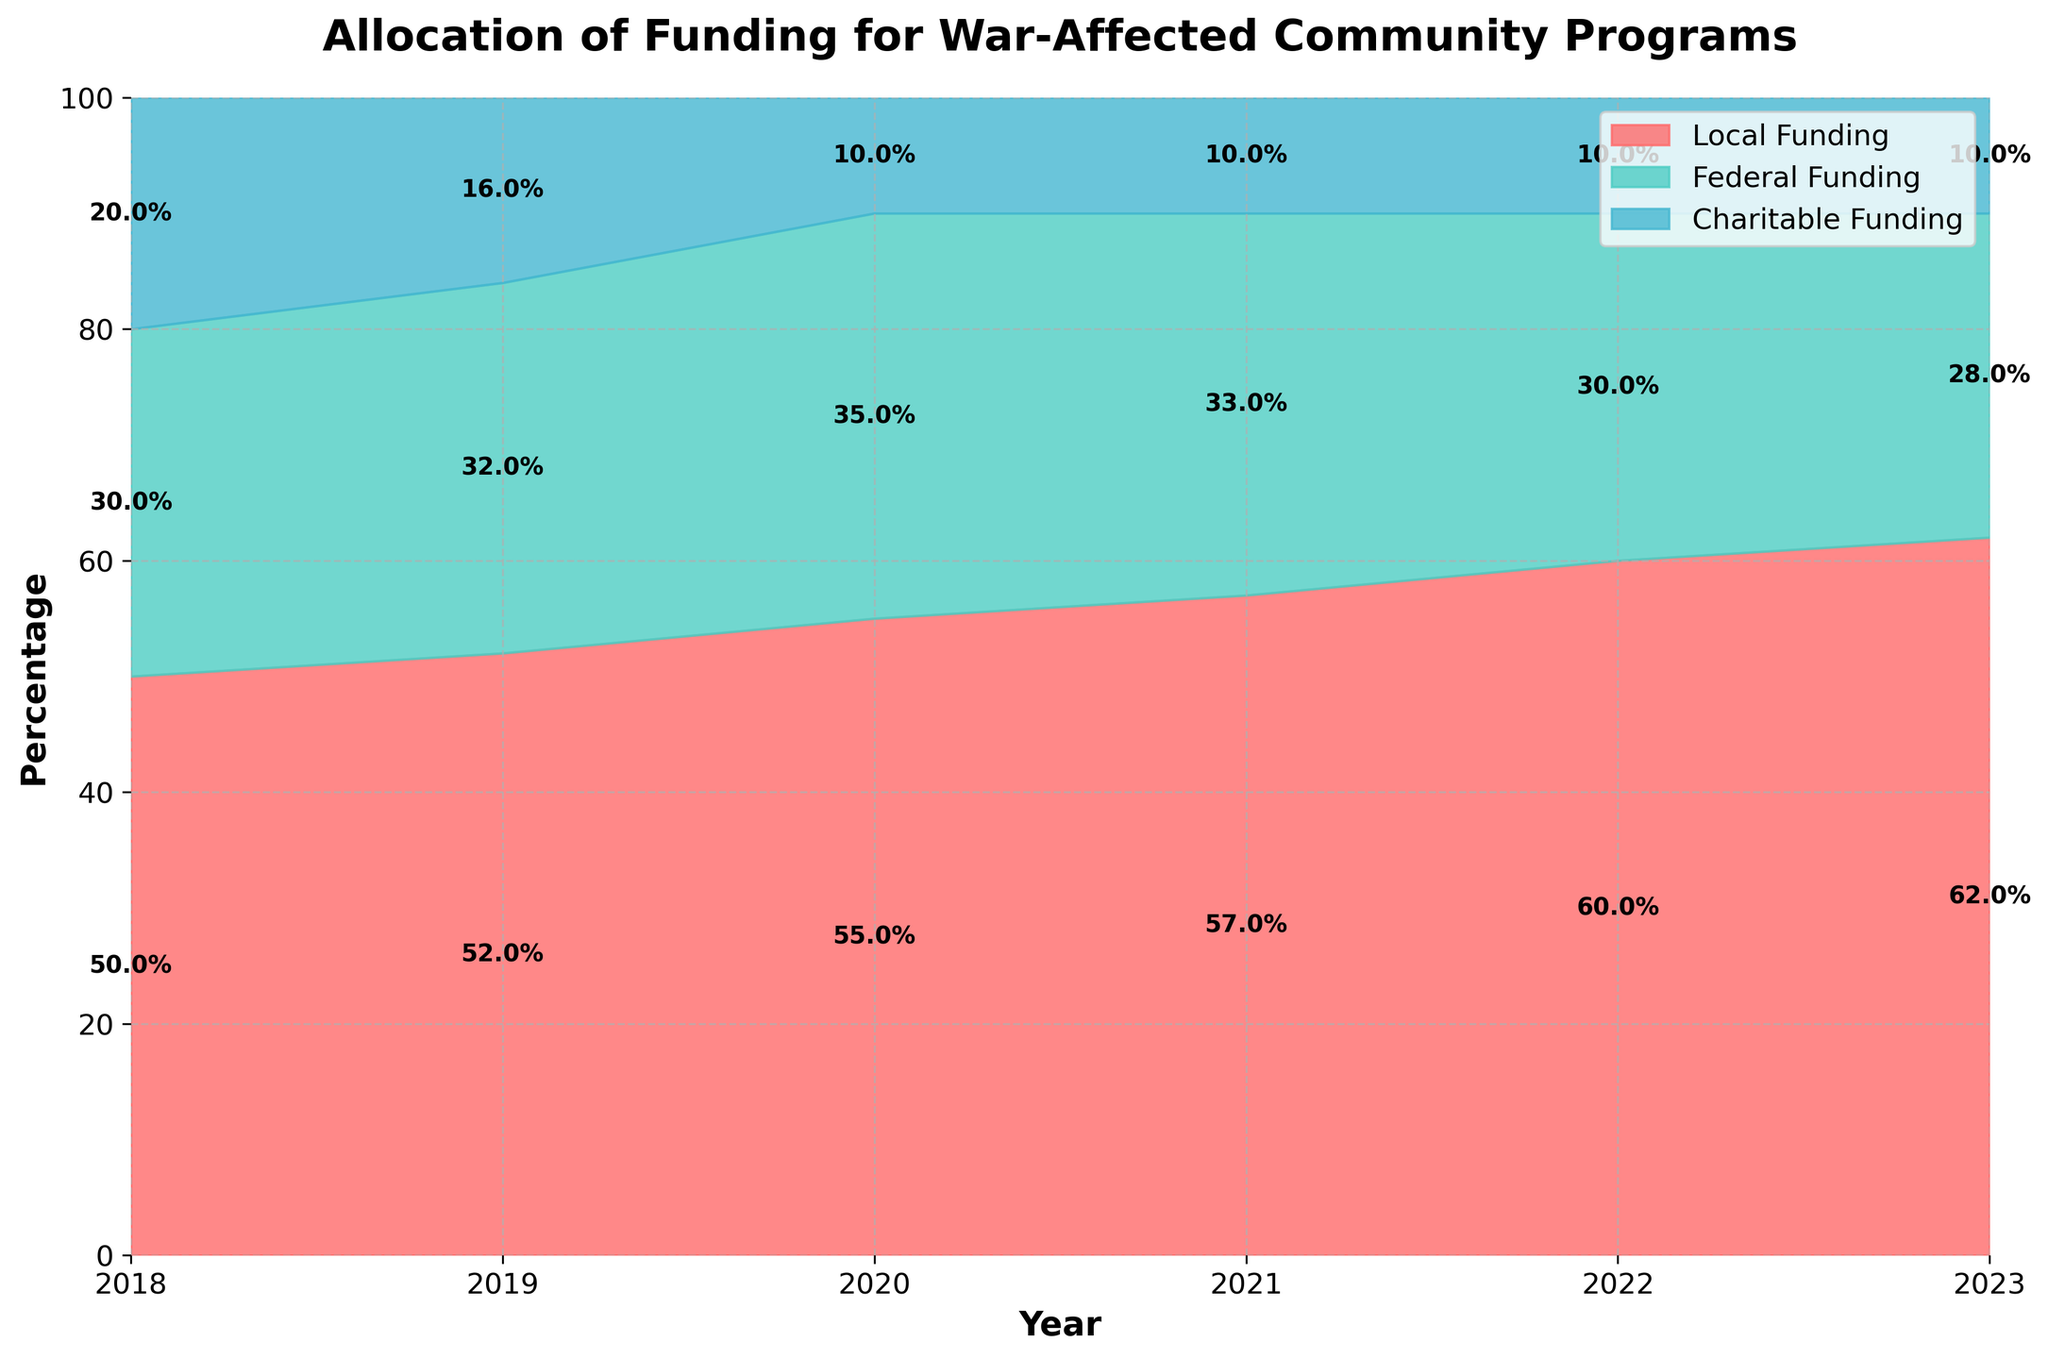What is the local funding percentage in 2023? The local funding percentage can be seen from the height of the red area in 2023. The label inside the red area shows 62.0%.
Answer: 62.0% What trend do you observe for charitable funding from 2018 to 2023? Charitable funding percentage is indicated by the blue area on top. From 2018 to 2023, the percentage decreases from 20% to 10%, suggesting a declining trend.
Answer: Declining trend How has the federal funding percentage changed between 2018 and 2020? Federal funding percentage is represented by the green area. In 2018, it is shown as 30%, and it increases to 35% in 2020.
Answer: Increased by 5% Which year had the highest share of local funding? Comparing the widths of the red areas across the years, the label shows that 2023 had the highest share of local funding at 62.0%.
Answer: 2023 Between 2020 and 2021, did the charitable funding percentage increase, decrease, or stay the same? From the labels on the blue area, the percentage of charitable funding remains the same at 10% for both years.
Answer: Stayed the same What is the total percentage of funding that comes from non-local sources in 2019? The funding from non-local sources in 2019 is the sum of the federal and charitable funding percentages. Federal funding is 32% and charitable funding is 16%, so the total is 32% + 16% = 48%.
Answer: 48% In which year did federal funding see a drop in its percentage while local funding increased? Comparing the green and red areas, 2021 shows a drop in federal funding (to 33%) compared to 2020 (35%), while local funding increased from 55% in 2020 to 57% in 2021.
Answer: 2021 Based on the chart, what can you infer about the stability of charitable funding over the years? The blue areas are fairly consistent, dropping initially and then stabilizing at 10% from 2020 onwards, indicating stabilized but reduced levels of charitable funding.
Answer: Stabilized but reduced Which funding source saw the most significant change during the period shown? By comparing area sizes and percentages, charitable funding saw the most significant change, dropping from 20% in 2018 to 10% by 2020 and staying there.
Answer: Charitable funding If you sum the local and federal funding percentages for 2022, what is the total? From the labels in the red and green areas for 2022, local funding is 60% and federal is 30%. Summing these: 60% + 30% = 90%.
Answer: 90% 